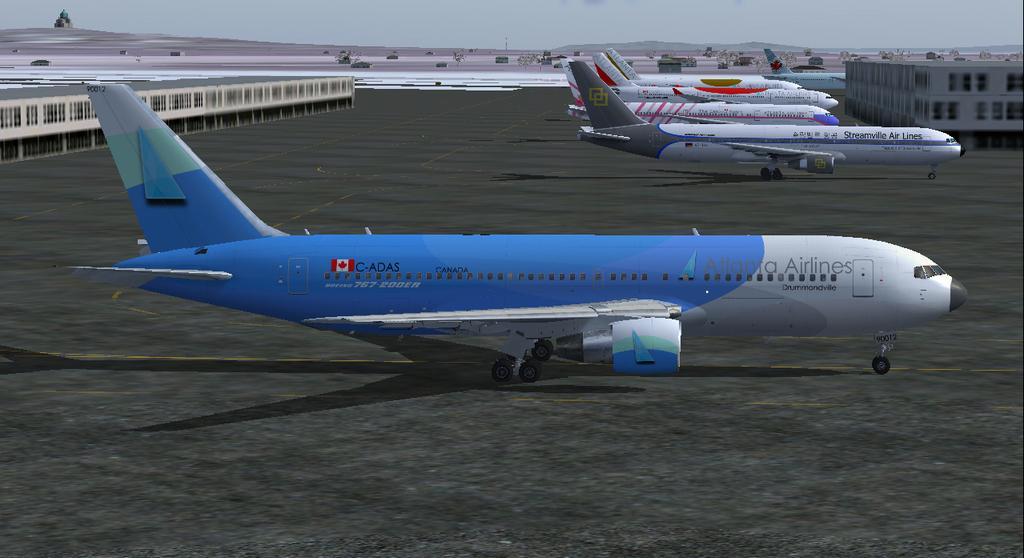In one or two sentences, can you explain what this image depicts? In this image there are flights on the runway, buildings, few stones, plants, mountains, a tower and the sky. 